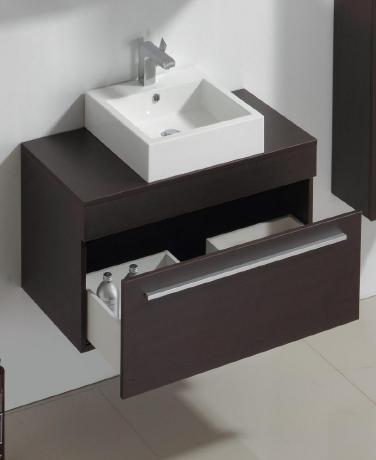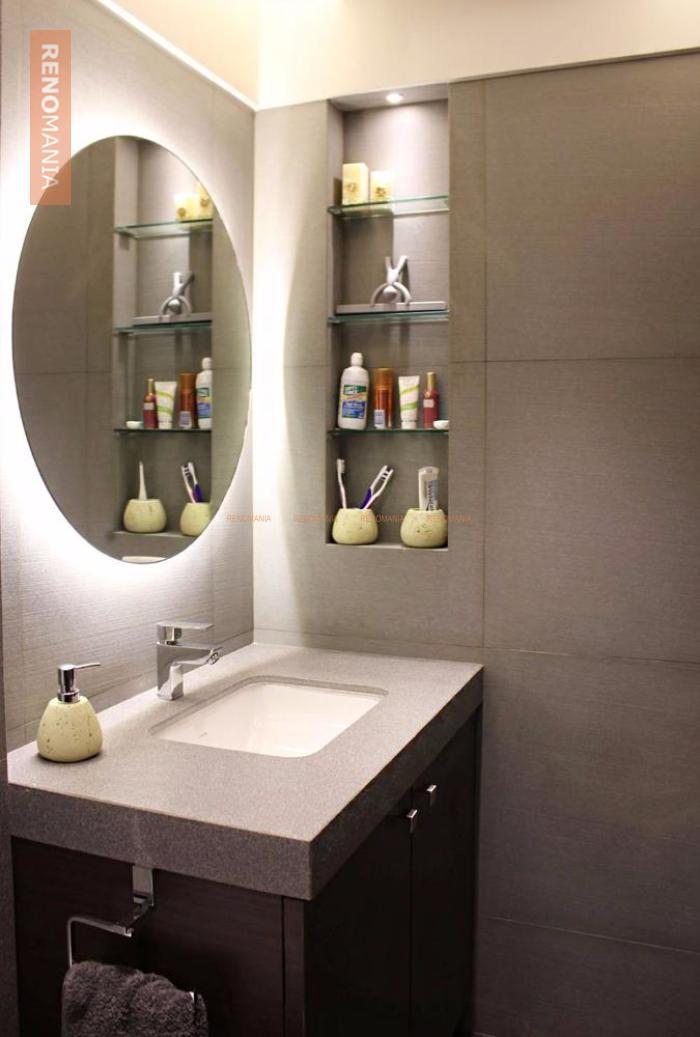The first image is the image on the left, the second image is the image on the right. Evaluate the accuracy of this statement regarding the images: "Greenery can be seen past the sink on the left.". Is it true? Answer yes or no. No. 